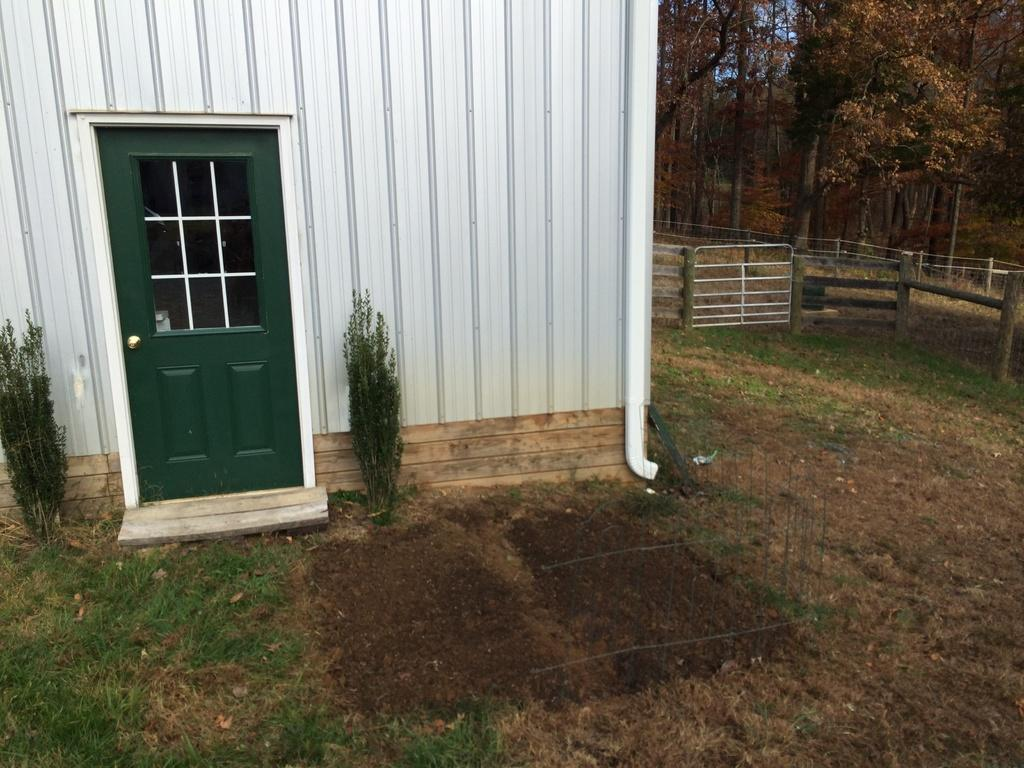What type of structure is present in the image? There is a house in the image. What feature is present on the house? The house has a door. Are there any plants visible in the image? Yes, there are two plants in the image. What type of ground surface is present in the image? There is grass on the ground. What is located on the right side of the image? There is a fence on the right side of the image. What type of vegetation can be seen in the image besides the plants? There are trees in the image. Can you tell me how many actors are kissing in the image? There are no actors or kissing present in the image. What type of yarn is being used to decorate the house in the image? There is no yarn present in the image. 